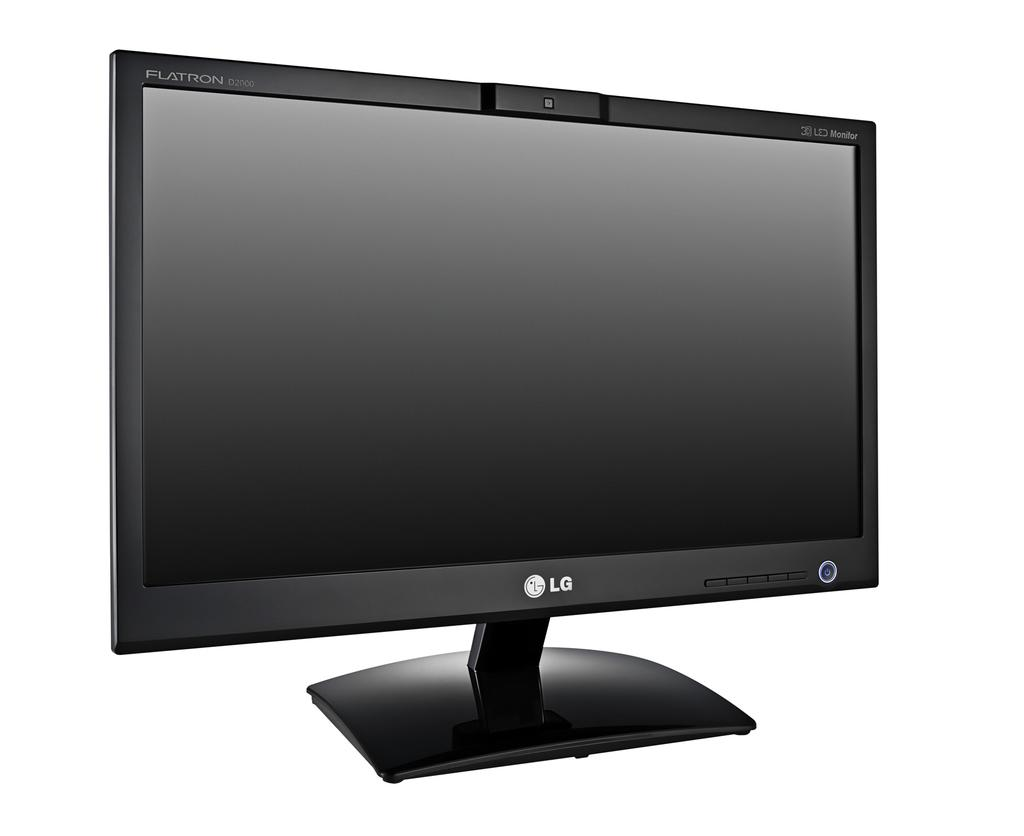<image>
Give a short and clear explanation of the subsequent image. An LG television that is turned off with a white background 